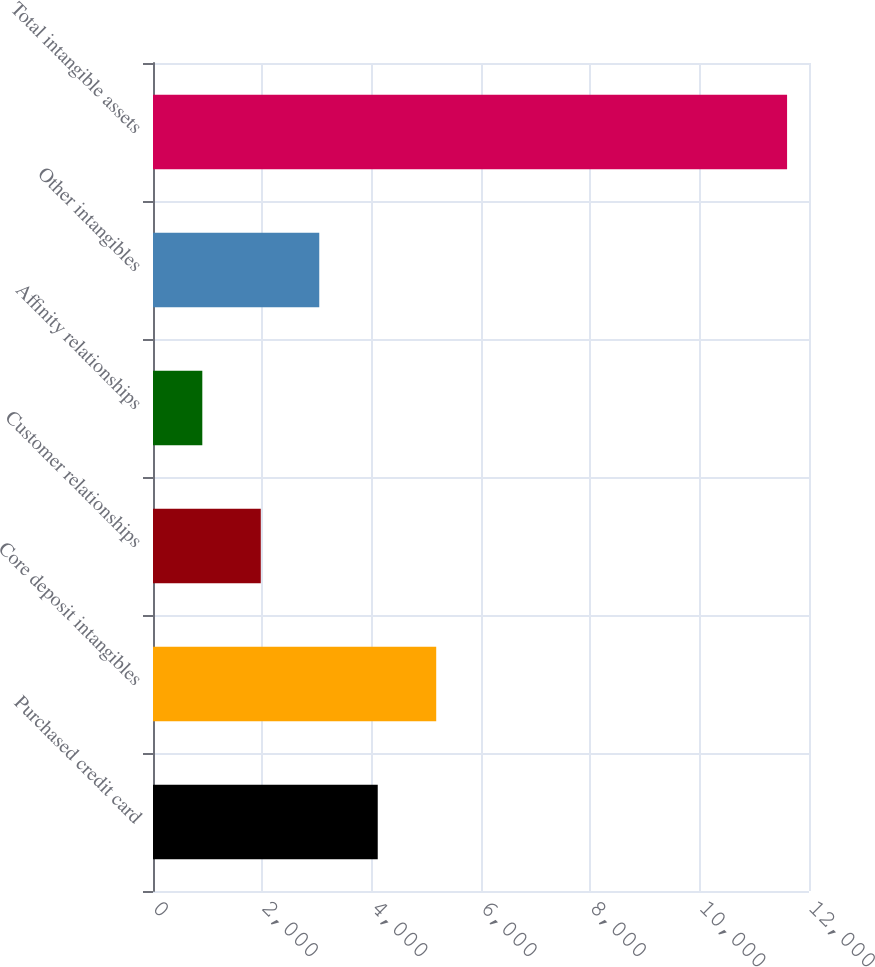Convert chart to OTSL. <chart><loc_0><loc_0><loc_500><loc_500><bar_chart><fcel>Purchased credit card<fcel>Core deposit intangibles<fcel>Customer relationships<fcel>Affinity relationships<fcel>Other intangibles<fcel>Total intangible assets<nl><fcel>4111.1<fcel>5180.8<fcel>1971.7<fcel>902<fcel>3041.4<fcel>11599<nl></chart> 